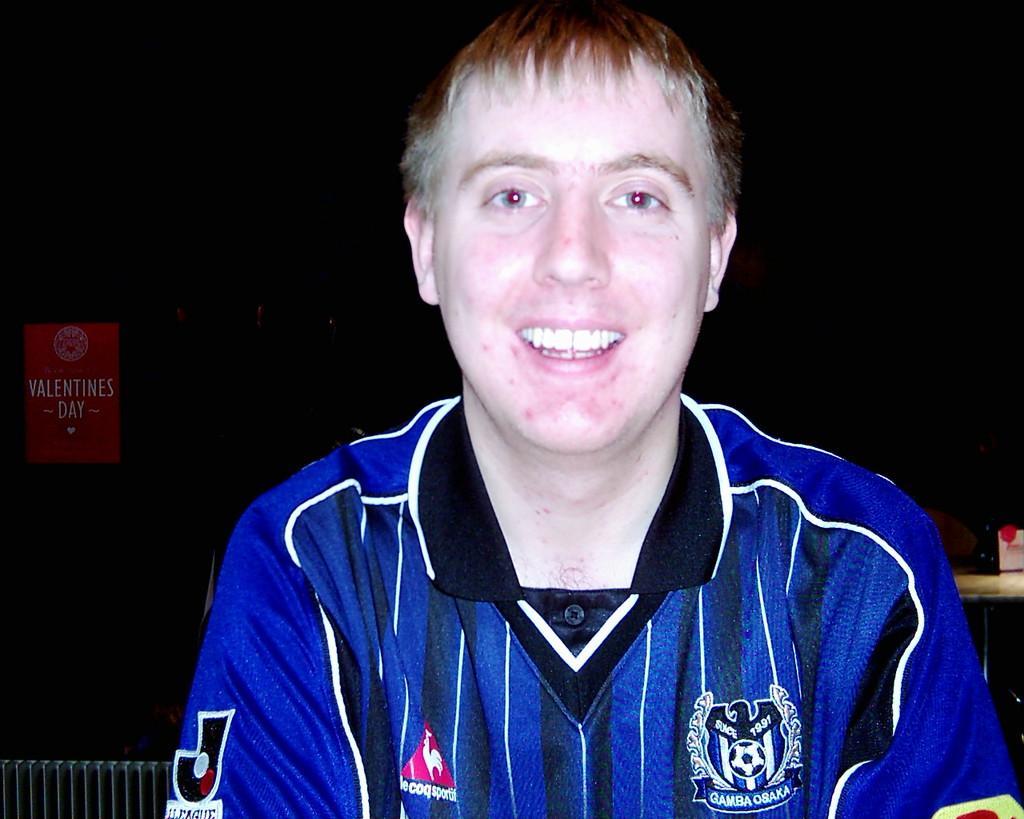Could you give a brief overview of what you see in this image? In this picture I can see there is a person sitting, smiling and he is wearing a blue color jersey and the backdrop of the image is dark, there is a red color poster at left side. 